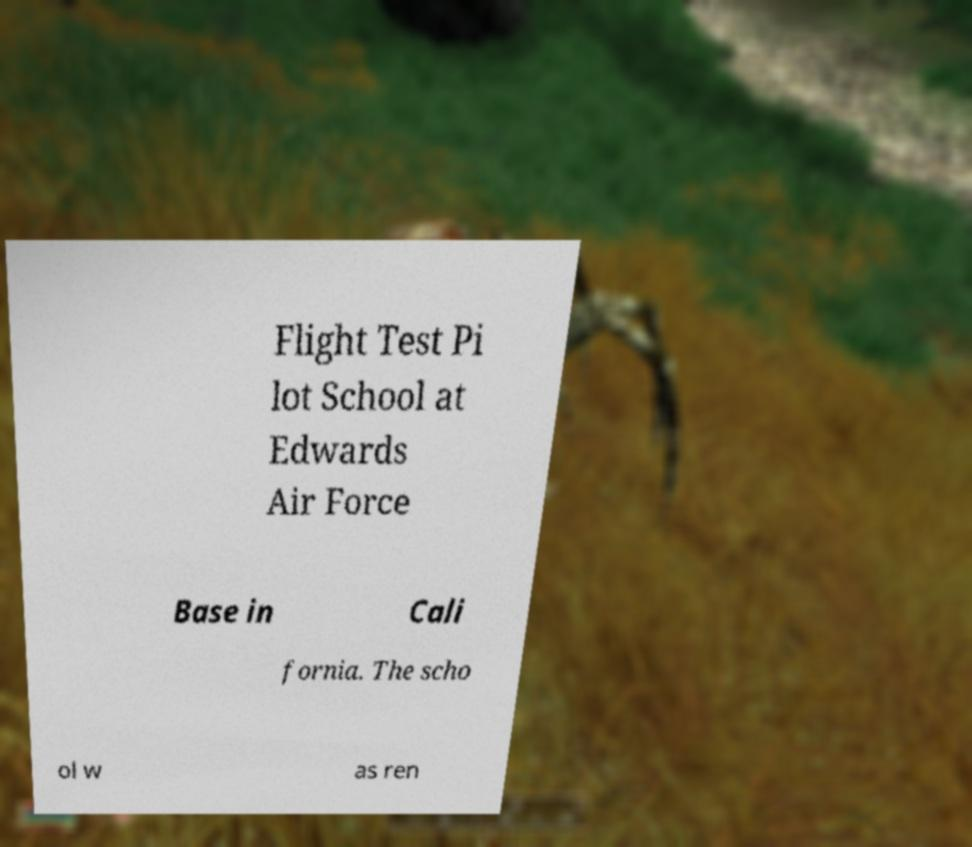Can you accurately transcribe the text from the provided image for me? Flight Test Pi lot School at Edwards Air Force Base in Cali fornia. The scho ol w as ren 